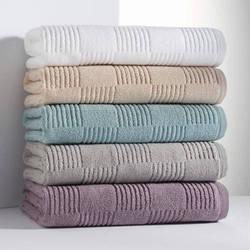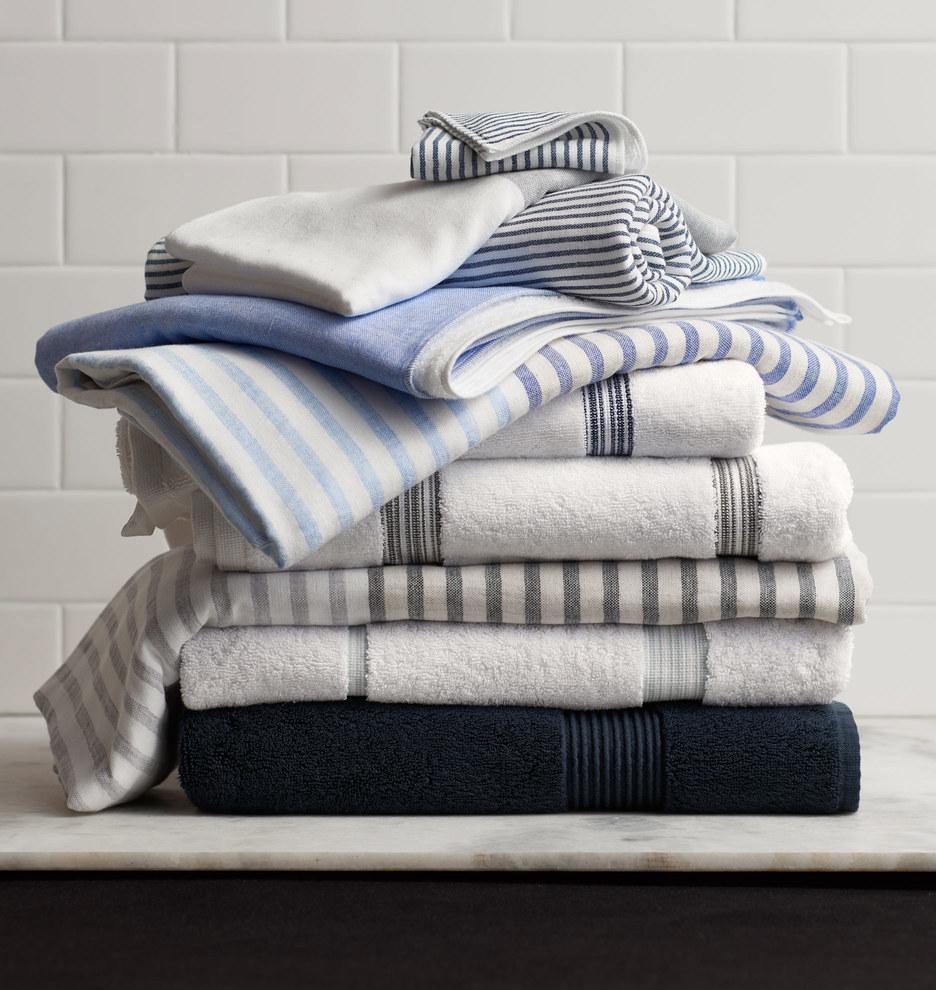The first image is the image on the left, the second image is the image on the right. Given the left and right images, does the statement "The leftmost images feature a stack of grey towels." hold true? Answer yes or no. No. The first image is the image on the left, the second image is the image on the right. Assess this claim about the two images: "The towels in the image on the left are gray.". Correct or not? Answer yes or no. No. 